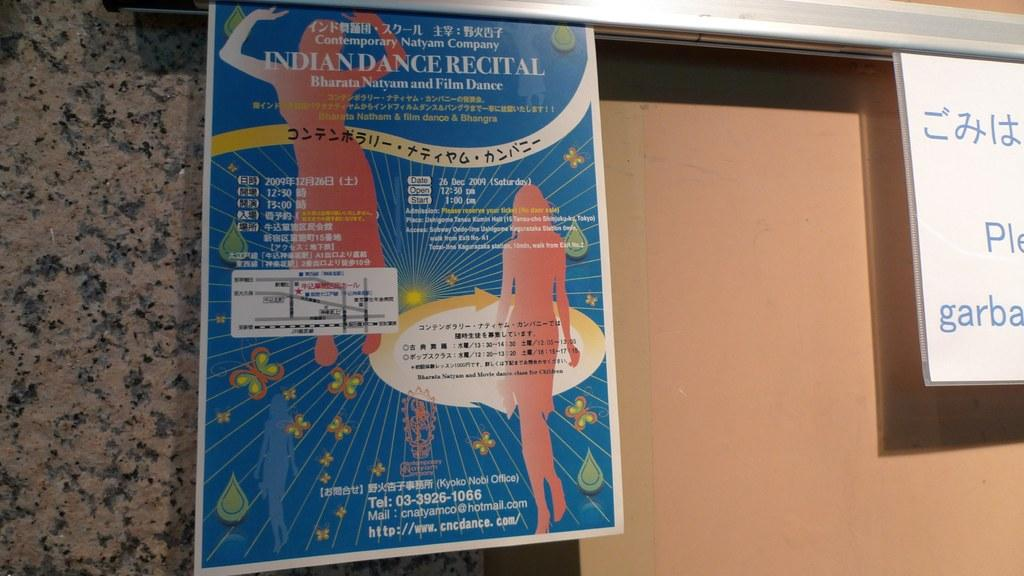<image>
Create a compact narrative representing the image presented. A large blue poster contains a lot of information about an Indian Dance Recital. 